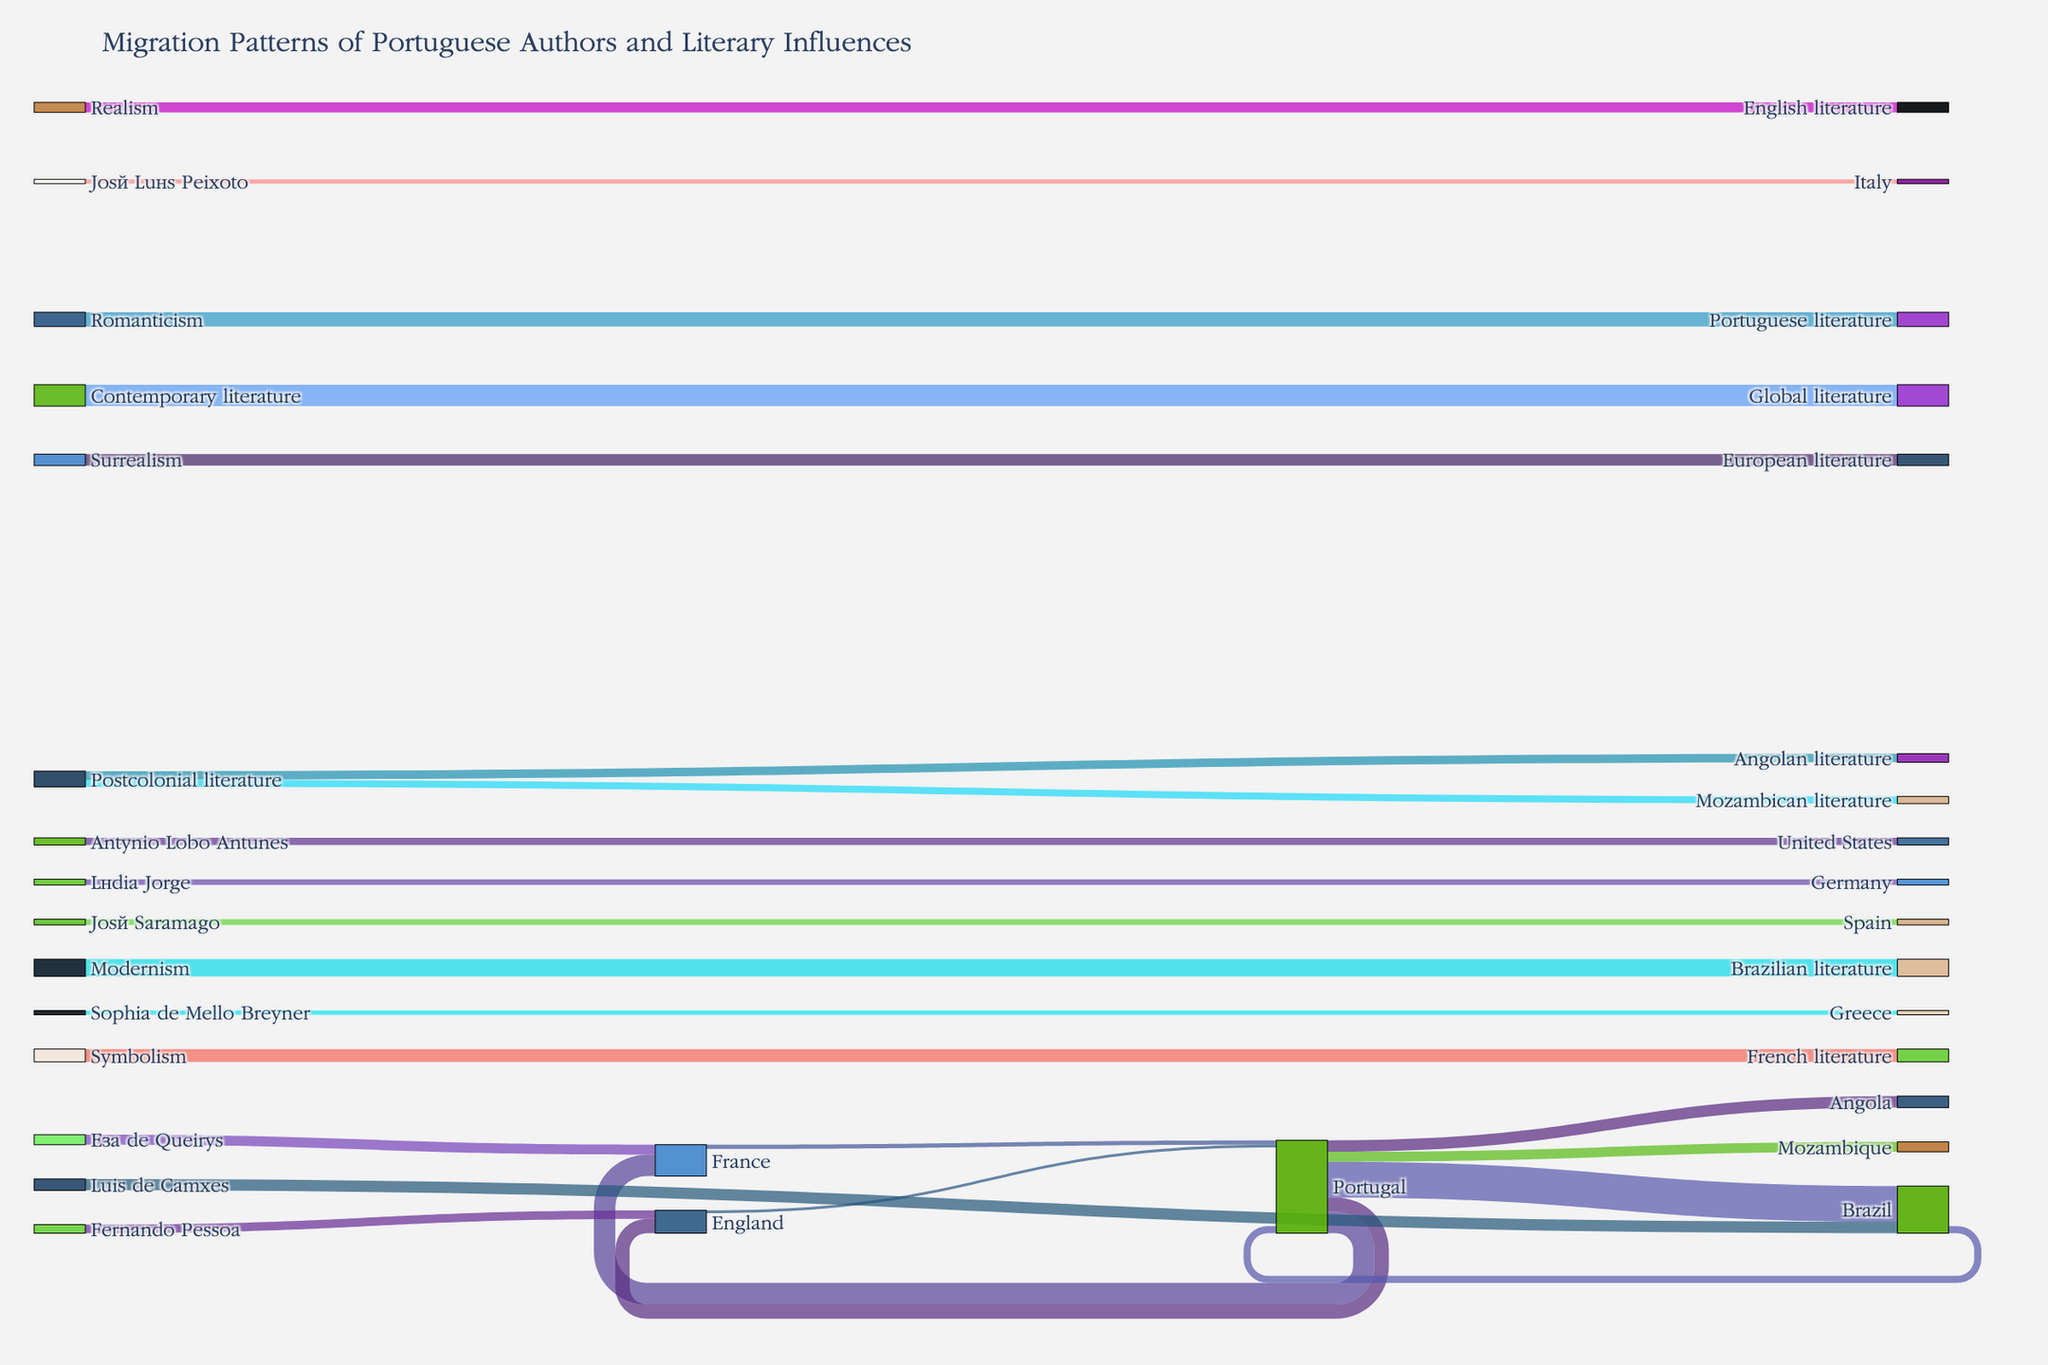What is the title of the Sankey diagram? The title is displayed at the top of the Sankey diagram and it summarizes the theme of the visualization.
Answer: Migration Patterns of Portuguese Authors and Literary Influences Which destination has the highest number of migrations from Portugal? From the Sankey diagram, look for the node 'Portugal' and follow its connections to see which node has the largest flow.
Answer: Brazil How many authors migrated from Portugal to France? From the node 'Portugal,' follow the flow line that leads to 'France' and note the value associated with it.
Answer: 15 Which literary movement had the greatest impact on Brazilian literature? Follow the flow lines from the node representing each literary movement to 'Brazilian literature' and identify the largest value.
Answer: Modernism Compare the migration from Portugal to Angola and Mozambique. Which country received more authors and by how many? Follow the flow lines from 'Portugal' to both 'Angola' and 'Mozambique' and compare the values. Subtract the number of migrations to Mozambique from those to Angola.
Answer: Angola received 1 more author than Mozambique Identify one Portuguese author who impacted Greek literary scenes? Look for the Portuguese authors connected to 'Greece' and note the author associated with that flow.
Answer: Sophia de Mello Breyner What's the total number of migrations from Portugal to various countries? Sum the values of all flow lines originating from 'Portugal' to different countries.
Answer: 65 Calculate the total number of migrations between Brazil and Portugal. Find the values for migrations from 'Portugal' to 'Brazil' and from 'Brazil' to 'Portugal,' and sum them up.
Answer: 30 Which two literary movements influenced European literature, and what is the total impact value? Look for flow lines leading to 'European literature,' note the originating literary movements, and sum their values.
Answer: Surrealism and Contemporary literature; total impact value is 23 Which received more influence from Portuguese literary movements: Angolan literature or Mozambican literature, and by how many? Check the values of the flows leading to 'Angolan literature' and 'Mozambican literature' and compare them by subtraction.
Answer: Angolan literature received 1 more influence than Mozambican literature 